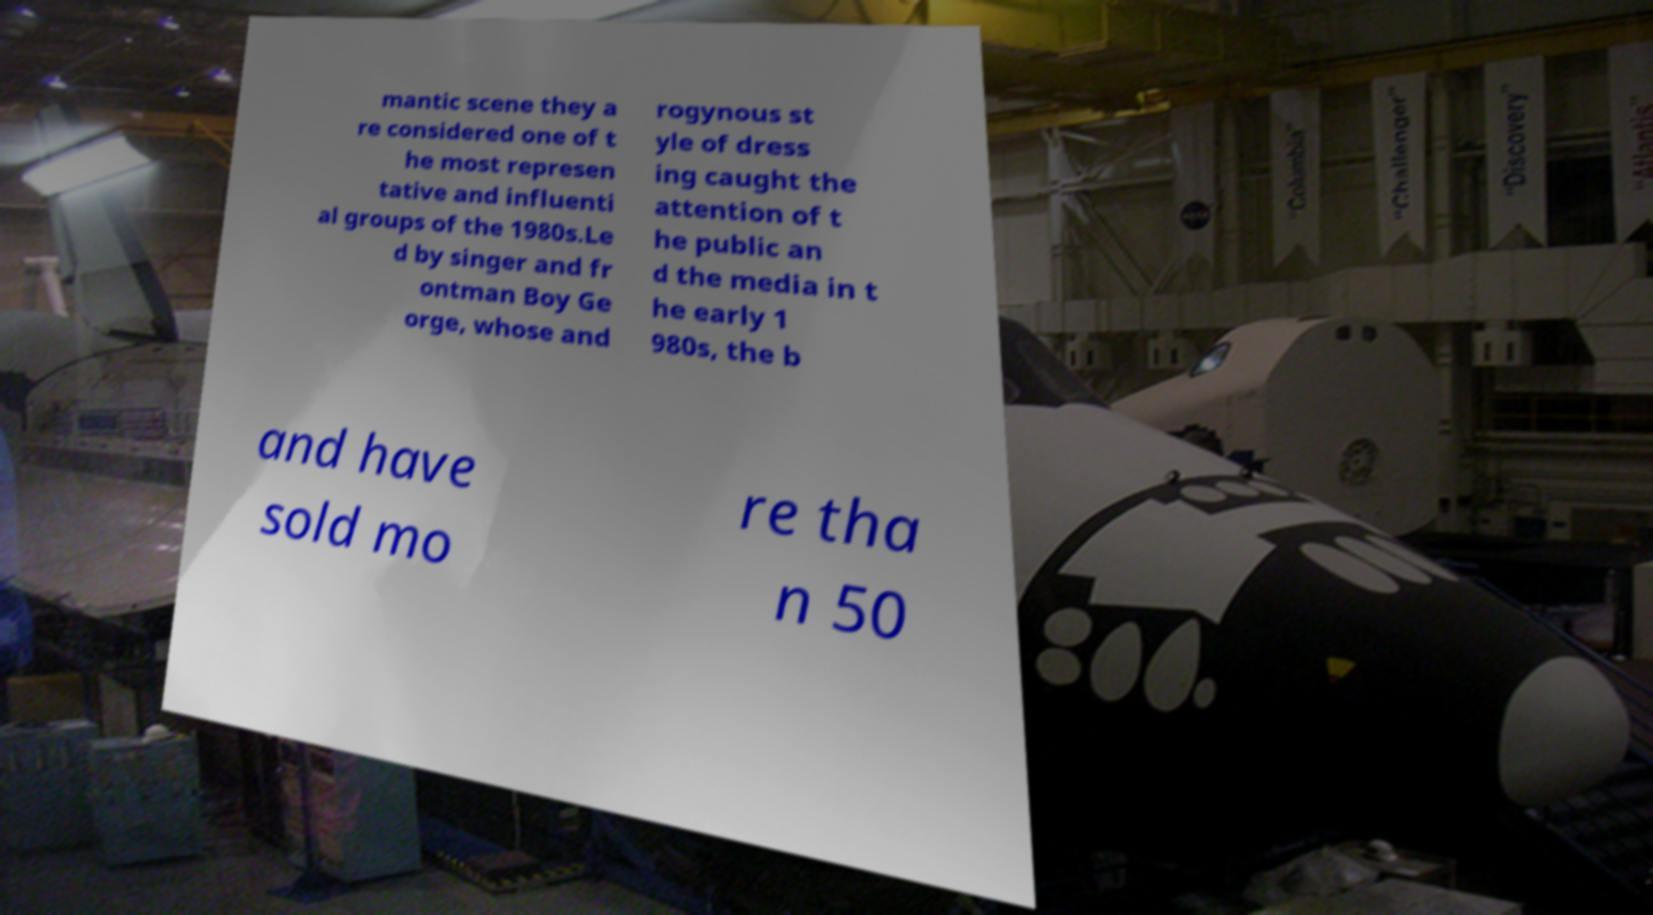For documentation purposes, I need the text within this image transcribed. Could you provide that? mantic scene they a re considered one of t he most represen tative and influenti al groups of the 1980s.Le d by singer and fr ontman Boy Ge orge, whose and rogynous st yle of dress ing caught the attention of t he public an d the media in t he early 1 980s, the b and have sold mo re tha n 50 